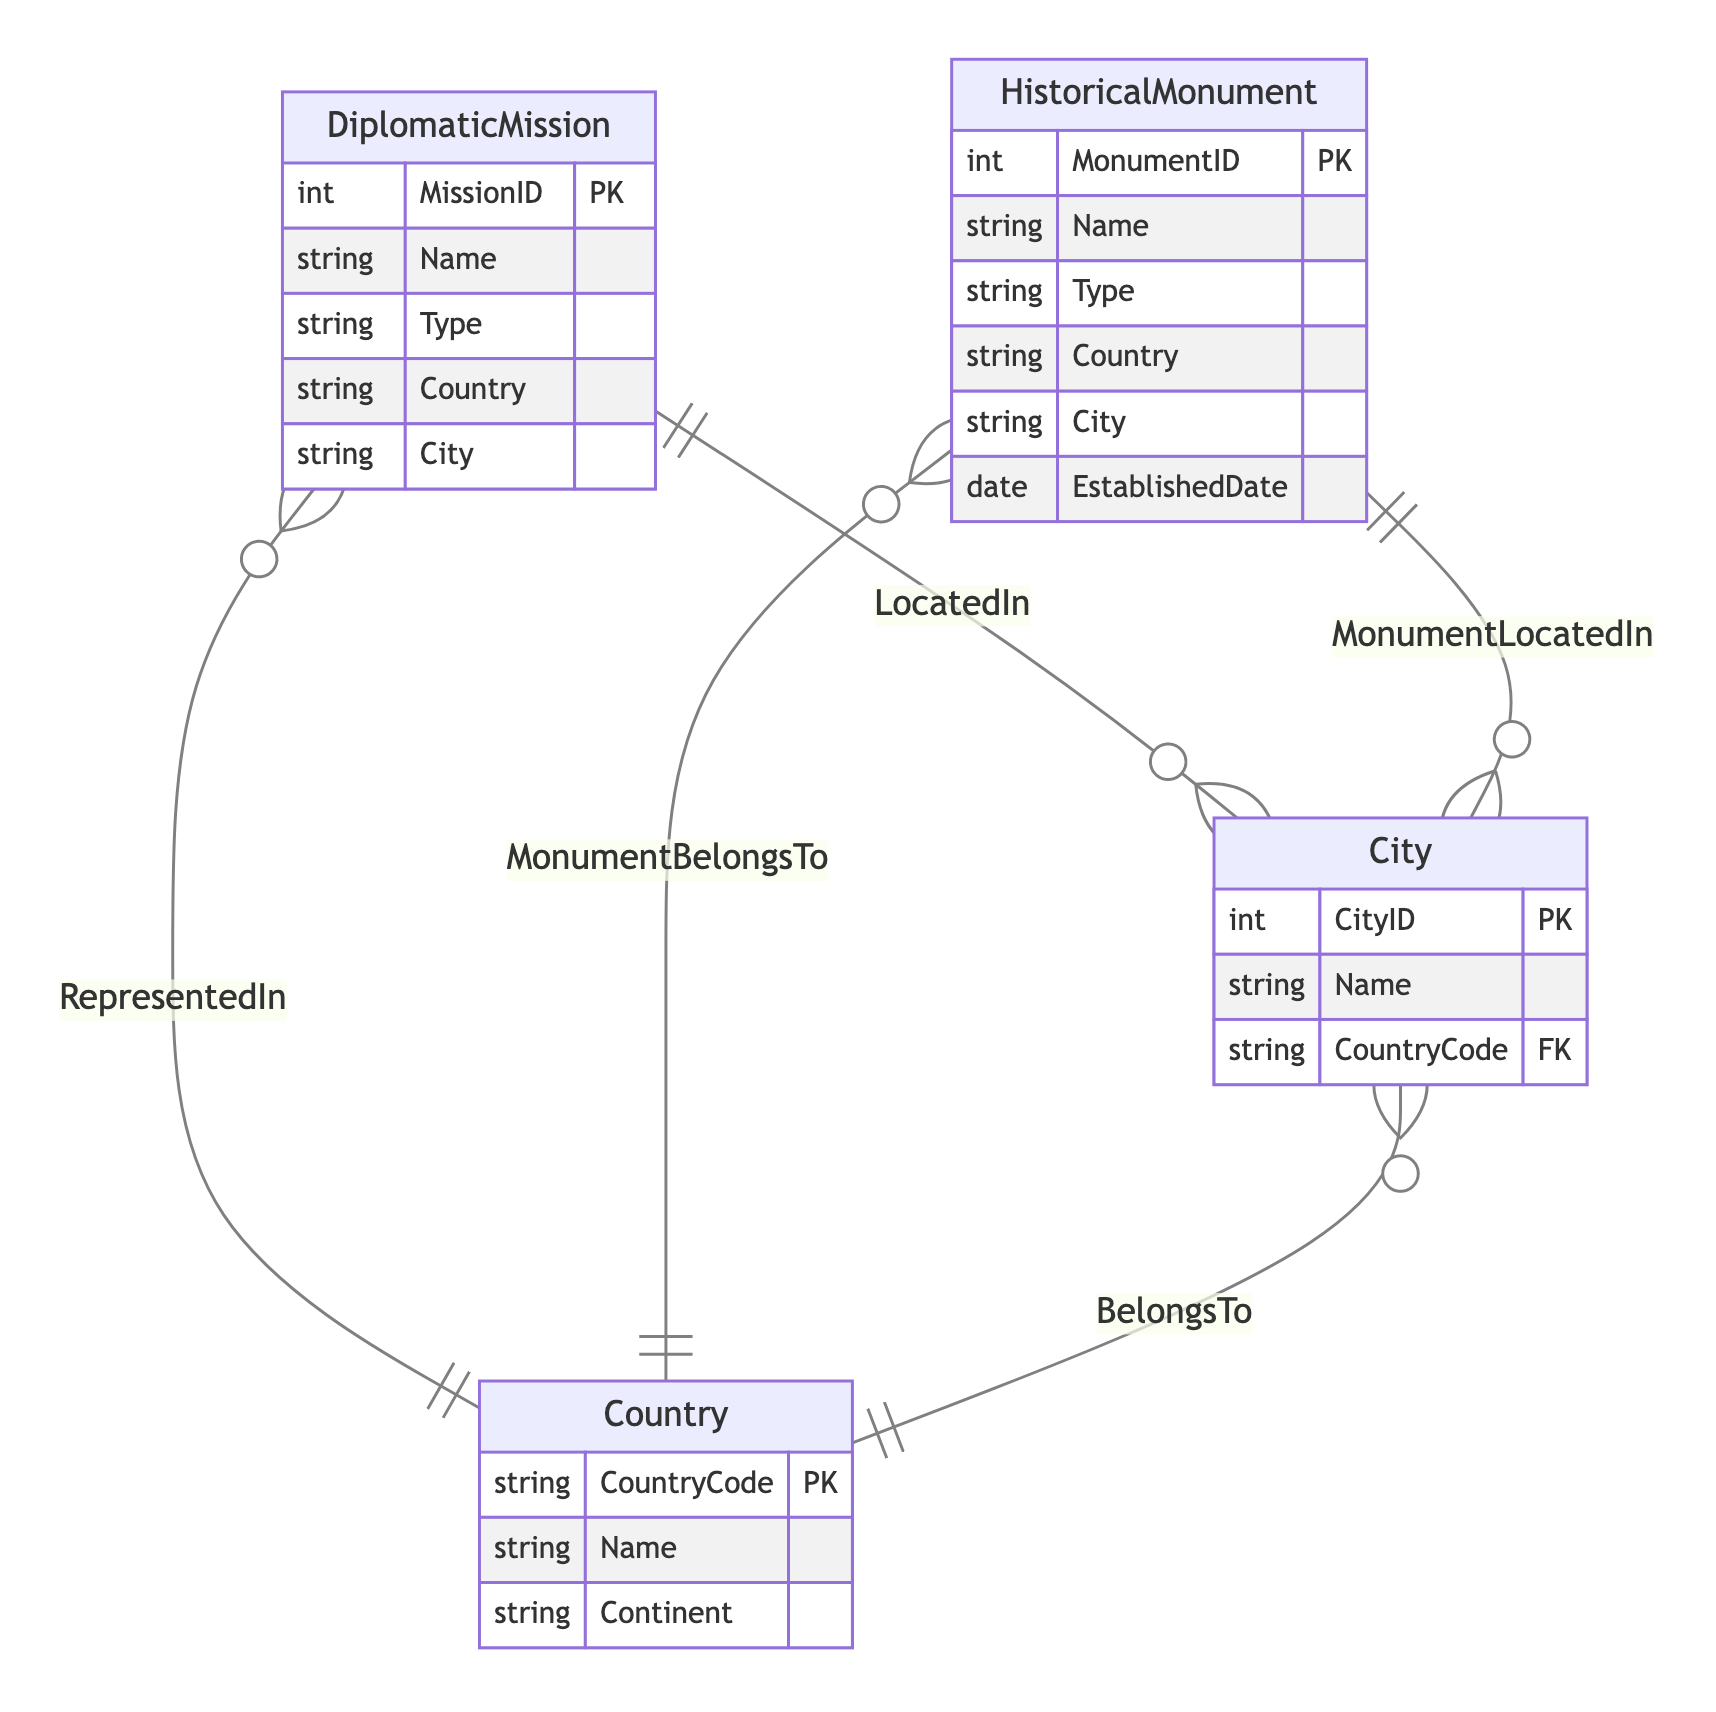What is the primary key of the DiplomaticMission entity? The primary key of the DiplomaticMission entity is MissionID, which uniquely identifies each diplomatic mission in the database.
Answer: MissionID How many attributes does the HistoricalMonument entity have? The HistoricalMonument entity has five attributes: MonumentID, Name, Type, Country, and EstablishedDate.
Answer: Five What is the relationship between DiplomaticMission and Country? The relationship between DiplomaticMission and Country is represented as "RepresentedIn", indicating that many diplomatic missions can represent a single country.
Answer: RepresentedIn Which entity is related to City with a "Many-to-One" cardinality? Both DiplomaticMission and HistoricalMonument are related to City with a "Many-to-One" cardinality, meaning many diplomatic missions or monuments can be located in a single city.
Answer: DiplomaticMission and HistoricalMonument What attribute type is CountryCode in the City entity? The CountryCode in the City entity is of type string, which is used to represent the unique code assigned to each country.
Answer: String What is the established date attribute in the HistoricalMonument entity? The established date attribute in the HistoricalMonument entity is EstablishedDate, which records when the monument was established.
Answer: EstablishedDate How many entities are there in total? There are four entities in total: DiplomaticMission, HistoricalMonument, Country, and City.
Answer: Four What does the "MonumentLocatedIn" relationship signify? The "MonumentLocatedIn" relationship signifies that each historical monument is located in one city, and that city can have many monuments.
Answer: MonumentLocatedIn What entity has the City as a foreign key? The City attribute serves as a foreign key in both DiplomaticMission and HistoricalMonument entities, linking them to the City entity.
Answer: DiplomaticMission and HistoricalMonument 